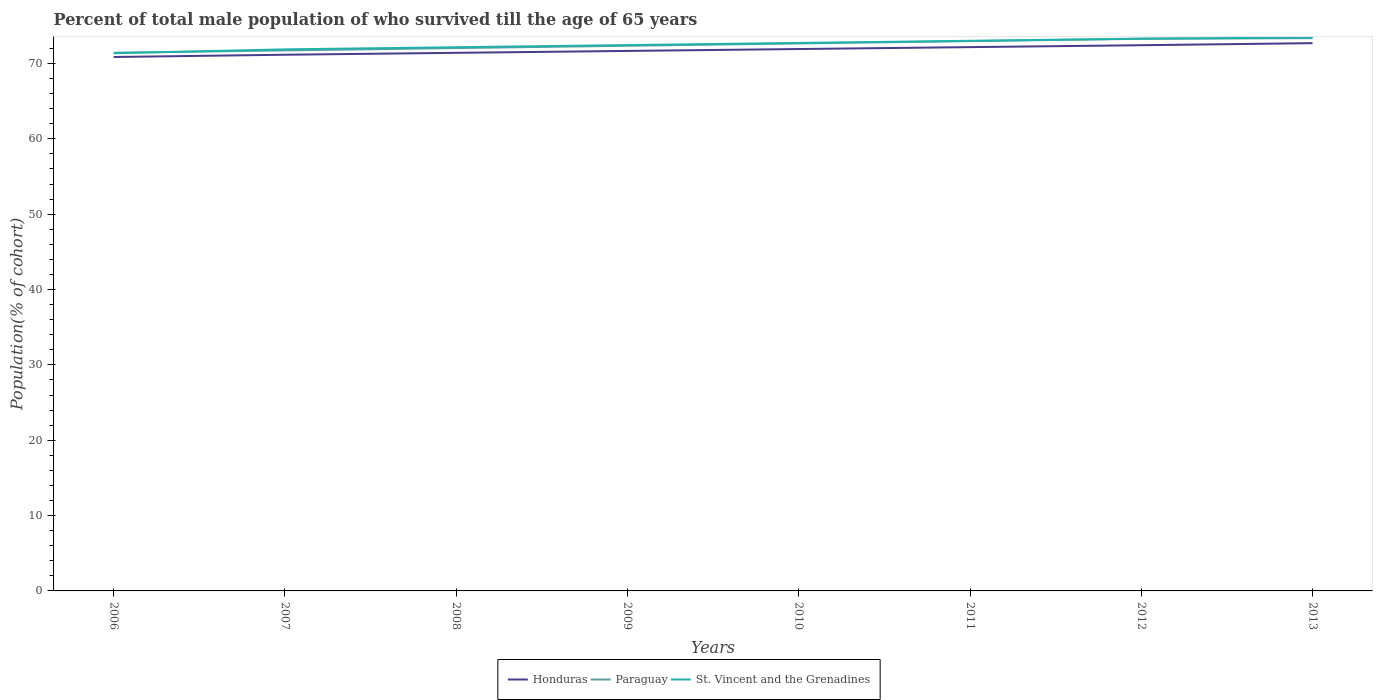Across all years, what is the maximum percentage of total male population who survived till the age of 65 years in Paraguay?
Provide a short and direct response. 71.43. What is the total percentage of total male population who survived till the age of 65 years in Honduras in the graph?
Your response must be concise. -0.5. What is the difference between the highest and the second highest percentage of total male population who survived till the age of 65 years in Honduras?
Keep it short and to the point. 1.84. What is the difference between the highest and the lowest percentage of total male population who survived till the age of 65 years in St. Vincent and the Grenadines?
Give a very brief answer. 4. How many years are there in the graph?
Ensure brevity in your answer.  8. What is the difference between two consecutive major ticks on the Y-axis?
Give a very brief answer. 10. Are the values on the major ticks of Y-axis written in scientific E-notation?
Give a very brief answer. No. Does the graph contain any zero values?
Keep it short and to the point. No. Does the graph contain grids?
Provide a short and direct response. No. What is the title of the graph?
Make the answer very short. Percent of total male population of who survived till the age of 65 years. What is the label or title of the Y-axis?
Your answer should be compact. Population(% of cohort). What is the Population(% of cohort) of Honduras in 2006?
Make the answer very short. 70.86. What is the Population(% of cohort) of Paraguay in 2006?
Your answer should be very brief. 71.43. What is the Population(% of cohort) in St. Vincent and the Grenadines in 2006?
Give a very brief answer. 71.36. What is the Population(% of cohort) of Honduras in 2007?
Offer a very short reply. 71.16. What is the Population(% of cohort) in Paraguay in 2007?
Your response must be concise. 71.74. What is the Population(% of cohort) in St. Vincent and the Grenadines in 2007?
Make the answer very short. 71.87. What is the Population(% of cohort) in Honduras in 2008?
Your answer should be compact. 71.41. What is the Population(% of cohort) of Paraguay in 2008?
Your answer should be very brief. 72.04. What is the Population(% of cohort) of St. Vincent and the Grenadines in 2008?
Provide a short and direct response. 72.16. What is the Population(% of cohort) of Honduras in 2009?
Offer a very short reply. 71.67. What is the Population(% of cohort) in Paraguay in 2009?
Keep it short and to the point. 72.35. What is the Population(% of cohort) in St. Vincent and the Grenadines in 2009?
Provide a succinct answer. 72.44. What is the Population(% of cohort) in Honduras in 2010?
Your response must be concise. 71.92. What is the Population(% of cohort) in Paraguay in 2010?
Give a very brief answer. 72.66. What is the Population(% of cohort) of St. Vincent and the Grenadines in 2010?
Your answer should be compact. 72.73. What is the Population(% of cohort) of Honduras in 2011?
Offer a very short reply. 72.17. What is the Population(% of cohort) of Paraguay in 2011?
Ensure brevity in your answer.  72.97. What is the Population(% of cohort) of St. Vincent and the Grenadines in 2011?
Offer a very short reply. 73.01. What is the Population(% of cohort) in Honduras in 2012?
Make the answer very short. 72.42. What is the Population(% of cohort) in Paraguay in 2012?
Provide a short and direct response. 73.28. What is the Population(% of cohort) of St. Vincent and the Grenadines in 2012?
Offer a very short reply. 73.3. What is the Population(% of cohort) in Honduras in 2013?
Provide a succinct answer. 72.7. What is the Population(% of cohort) of Paraguay in 2013?
Keep it short and to the point. 73.36. What is the Population(% of cohort) in St. Vincent and the Grenadines in 2013?
Your answer should be very brief. 73.44. Across all years, what is the maximum Population(% of cohort) of Honduras?
Your answer should be compact. 72.7. Across all years, what is the maximum Population(% of cohort) of Paraguay?
Provide a succinct answer. 73.36. Across all years, what is the maximum Population(% of cohort) of St. Vincent and the Grenadines?
Offer a terse response. 73.44. Across all years, what is the minimum Population(% of cohort) in Honduras?
Offer a very short reply. 70.86. Across all years, what is the minimum Population(% of cohort) of Paraguay?
Make the answer very short. 71.43. Across all years, what is the minimum Population(% of cohort) in St. Vincent and the Grenadines?
Make the answer very short. 71.36. What is the total Population(% of cohort) of Honduras in the graph?
Make the answer very short. 574.32. What is the total Population(% of cohort) in Paraguay in the graph?
Give a very brief answer. 579.83. What is the total Population(% of cohort) in St. Vincent and the Grenadines in the graph?
Your response must be concise. 580.31. What is the difference between the Population(% of cohort) in Honduras in 2006 and that in 2007?
Give a very brief answer. -0.3. What is the difference between the Population(% of cohort) in Paraguay in 2006 and that in 2007?
Ensure brevity in your answer.  -0.31. What is the difference between the Population(% of cohort) of St. Vincent and the Grenadines in 2006 and that in 2007?
Provide a succinct answer. -0.52. What is the difference between the Population(% of cohort) of Honduras in 2006 and that in 2008?
Provide a succinct answer. -0.55. What is the difference between the Population(% of cohort) of Paraguay in 2006 and that in 2008?
Provide a short and direct response. -0.62. What is the difference between the Population(% of cohort) of St. Vincent and the Grenadines in 2006 and that in 2008?
Your response must be concise. -0.8. What is the difference between the Population(% of cohort) of Honduras in 2006 and that in 2009?
Provide a short and direct response. -0.81. What is the difference between the Population(% of cohort) in Paraguay in 2006 and that in 2009?
Provide a succinct answer. -0.93. What is the difference between the Population(% of cohort) in St. Vincent and the Grenadines in 2006 and that in 2009?
Provide a succinct answer. -1.09. What is the difference between the Population(% of cohort) in Honduras in 2006 and that in 2010?
Offer a terse response. -1.06. What is the difference between the Population(% of cohort) of Paraguay in 2006 and that in 2010?
Give a very brief answer. -1.23. What is the difference between the Population(% of cohort) of St. Vincent and the Grenadines in 2006 and that in 2010?
Keep it short and to the point. -1.37. What is the difference between the Population(% of cohort) of Honduras in 2006 and that in 2011?
Provide a succinct answer. -1.31. What is the difference between the Population(% of cohort) in Paraguay in 2006 and that in 2011?
Ensure brevity in your answer.  -1.54. What is the difference between the Population(% of cohort) in St. Vincent and the Grenadines in 2006 and that in 2011?
Give a very brief answer. -1.65. What is the difference between the Population(% of cohort) in Honduras in 2006 and that in 2012?
Provide a short and direct response. -1.56. What is the difference between the Population(% of cohort) of Paraguay in 2006 and that in 2012?
Provide a short and direct response. -1.85. What is the difference between the Population(% of cohort) of St. Vincent and the Grenadines in 2006 and that in 2012?
Offer a very short reply. -1.94. What is the difference between the Population(% of cohort) in Honduras in 2006 and that in 2013?
Provide a succinct answer. -1.84. What is the difference between the Population(% of cohort) of Paraguay in 2006 and that in 2013?
Make the answer very short. -1.94. What is the difference between the Population(% of cohort) in St. Vincent and the Grenadines in 2006 and that in 2013?
Ensure brevity in your answer.  -2.08. What is the difference between the Population(% of cohort) of Honduras in 2007 and that in 2008?
Your answer should be compact. -0.25. What is the difference between the Population(% of cohort) in Paraguay in 2007 and that in 2008?
Your answer should be compact. -0.31. What is the difference between the Population(% of cohort) in St. Vincent and the Grenadines in 2007 and that in 2008?
Provide a succinct answer. -0.28. What is the difference between the Population(% of cohort) of Honduras in 2007 and that in 2009?
Your answer should be compact. -0.5. What is the difference between the Population(% of cohort) in Paraguay in 2007 and that in 2009?
Offer a very short reply. -0.62. What is the difference between the Population(% of cohort) of St. Vincent and the Grenadines in 2007 and that in 2009?
Provide a short and direct response. -0.57. What is the difference between the Population(% of cohort) of Honduras in 2007 and that in 2010?
Give a very brief answer. -0.76. What is the difference between the Population(% of cohort) of Paraguay in 2007 and that in 2010?
Offer a very short reply. -0.92. What is the difference between the Population(% of cohort) of St. Vincent and the Grenadines in 2007 and that in 2010?
Keep it short and to the point. -0.85. What is the difference between the Population(% of cohort) in Honduras in 2007 and that in 2011?
Provide a short and direct response. -1.01. What is the difference between the Population(% of cohort) of Paraguay in 2007 and that in 2011?
Give a very brief answer. -1.23. What is the difference between the Population(% of cohort) in St. Vincent and the Grenadines in 2007 and that in 2011?
Ensure brevity in your answer.  -1.14. What is the difference between the Population(% of cohort) of Honduras in 2007 and that in 2012?
Provide a succinct answer. -1.26. What is the difference between the Population(% of cohort) in Paraguay in 2007 and that in 2012?
Offer a terse response. -1.54. What is the difference between the Population(% of cohort) in St. Vincent and the Grenadines in 2007 and that in 2012?
Your answer should be compact. -1.42. What is the difference between the Population(% of cohort) of Honduras in 2007 and that in 2013?
Give a very brief answer. -1.54. What is the difference between the Population(% of cohort) of Paraguay in 2007 and that in 2013?
Offer a terse response. -1.63. What is the difference between the Population(% of cohort) of St. Vincent and the Grenadines in 2007 and that in 2013?
Offer a very short reply. -1.57. What is the difference between the Population(% of cohort) in Honduras in 2008 and that in 2009?
Provide a short and direct response. -0.25. What is the difference between the Population(% of cohort) in Paraguay in 2008 and that in 2009?
Provide a short and direct response. -0.31. What is the difference between the Population(% of cohort) of St. Vincent and the Grenadines in 2008 and that in 2009?
Keep it short and to the point. -0.28. What is the difference between the Population(% of cohort) of Honduras in 2008 and that in 2010?
Provide a short and direct response. -0.5. What is the difference between the Population(% of cohort) of Paraguay in 2008 and that in 2010?
Your answer should be very brief. -0.62. What is the difference between the Population(% of cohort) in St. Vincent and the Grenadines in 2008 and that in 2010?
Make the answer very short. -0.57. What is the difference between the Population(% of cohort) of Honduras in 2008 and that in 2011?
Make the answer very short. -0.76. What is the difference between the Population(% of cohort) of Paraguay in 2008 and that in 2011?
Give a very brief answer. -0.92. What is the difference between the Population(% of cohort) of St. Vincent and the Grenadines in 2008 and that in 2011?
Offer a very short reply. -0.85. What is the difference between the Population(% of cohort) of Honduras in 2008 and that in 2012?
Provide a short and direct response. -1.01. What is the difference between the Population(% of cohort) in Paraguay in 2008 and that in 2012?
Offer a terse response. -1.23. What is the difference between the Population(% of cohort) in St. Vincent and the Grenadines in 2008 and that in 2012?
Offer a very short reply. -1.14. What is the difference between the Population(% of cohort) of Honduras in 2008 and that in 2013?
Provide a short and direct response. -1.28. What is the difference between the Population(% of cohort) in Paraguay in 2008 and that in 2013?
Give a very brief answer. -1.32. What is the difference between the Population(% of cohort) in St. Vincent and the Grenadines in 2008 and that in 2013?
Provide a succinct answer. -1.28. What is the difference between the Population(% of cohort) in Honduras in 2009 and that in 2010?
Keep it short and to the point. -0.25. What is the difference between the Population(% of cohort) of Paraguay in 2009 and that in 2010?
Your answer should be very brief. -0.31. What is the difference between the Population(% of cohort) in St. Vincent and the Grenadines in 2009 and that in 2010?
Offer a terse response. -0.28. What is the difference between the Population(% of cohort) of Honduras in 2009 and that in 2011?
Keep it short and to the point. -0.5. What is the difference between the Population(% of cohort) of Paraguay in 2009 and that in 2011?
Your answer should be compact. -0.62. What is the difference between the Population(% of cohort) in St. Vincent and the Grenadines in 2009 and that in 2011?
Ensure brevity in your answer.  -0.57. What is the difference between the Population(% of cohort) of Honduras in 2009 and that in 2012?
Keep it short and to the point. -0.76. What is the difference between the Population(% of cohort) of Paraguay in 2009 and that in 2012?
Your answer should be very brief. -0.92. What is the difference between the Population(% of cohort) of St. Vincent and the Grenadines in 2009 and that in 2012?
Provide a short and direct response. -0.85. What is the difference between the Population(% of cohort) in Honduras in 2009 and that in 2013?
Offer a terse response. -1.03. What is the difference between the Population(% of cohort) of Paraguay in 2009 and that in 2013?
Your answer should be very brief. -1.01. What is the difference between the Population(% of cohort) of St. Vincent and the Grenadines in 2009 and that in 2013?
Ensure brevity in your answer.  -1. What is the difference between the Population(% of cohort) in Honduras in 2010 and that in 2011?
Make the answer very short. -0.25. What is the difference between the Population(% of cohort) in Paraguay in 2010 and that in 2011?
Offer a terse response. -0.31. What is the difference between the Population(% of cohort) of St. Vincent and the Grenadines in 2010 and that in 2011?
Make the answer very short. -0.28. What is the difference between the Population(% of cohort) of Honduras in 2010 and that in 2012?
Offer a very short reply. -0.5. What is the difference between the Population(% of cohort) of Paraguay in 2010 and that in 2012?
Offer a very short reply. -0.62. What is the difference between the Population(% of cohort) of St. Vincent and the Grenadines in 2010 and that in 2012?
Offer a very short reply. -0.57. What is the difference between the Population(% of cohort) of Honduras in 2010 and that in 2013?
Ensure brevity in your answer.  -0.78. What is the difference between the Population(% of cohort) of Paraguay in 2010 and that in 2013?
Offer a terse response. -0.7. What is the difference between the Population(% of cohort) of St. Vincent and the Grenadines in 2010 and that in 2013?
Ensure brevity in your answer.  -0.72. What is the difference between the Population(% of cohort) in Honduras in 2011 and that in 2012?
Provide a succinct answer. -0.25. What is the difference between the Population(% of cohort) in Paraguay in 2011 and that in 2012?
Make the answer very short. -0.31. What is the difference between the Population(% of cohort) in St. Vincent and the Grenadines in 2011 and that in 2012?
Offer a very short reply. -0.28. What is the difference between the Population(% of cohort) of Honduras in 2011 and that in 2013?
Offer a very short reply. -0.53. What is the difference between the Population(% of cohort) in Paraguay in 2011 and that in 2013?
Your response must be concise. -0.4. What is the difference between the Population(% of cohort) in St. Vincent and the Grenadines in 2011 and that in 2013?
Offer a terse response. -0.43. What is the difference between the Population(% of cohort) of Honduras in 2012 and that in 2013?
Offer a very short reply. -0.27. What is the difference between the Population(% of cohort) in Paraguay in 2012 and that in 2013?
Offer a terse response. -0.09. What is the difference between the Population(% of cohort) of St. Vincent and the Grenadines in 2012 and that in 2013?
Your answer should be very brief. -0.15. What is the difference between the Population(% of cohort) of Honduras in 2006 and the Population(% of cohort) of Paraguay in 2007?
Offer a terse response. -0.87. What is the difference between the Population(% of cohort) of Honduras in 2006 and the Population(% of cohort) of St. Vincent and the Grenadines in 2007?
Provide a succinct answer. -1.01. What is the difference between the Population(% of cohort) of Paraguay in 2006 and the Population(% of cohort) of St. Vincent and the Grenadines in 2007?
Provide a short and direct response. -0.45. What is the difference between the Population(% of cohort) of Honduras in 2006 and the Population(% of cohort) of Paraguay in 2008?
Provide a short and direct response. -1.18. What is the difference between the Population(% of cohort) of Honduras in 2006 and the Population(% of cohort) of St. Vincent and the Grenadines in 2008?
Provide a short and direct response. -1.3. What is the difference between the Population(% of cohort) of Paraguay in 2006 and the Population(% of cohort) of St. Vincent and the Grenadines in 2008?
Keep it short and to the point. -0.73. What is the difference between the Population(% of cohort) of Honduras in 2006 and the Population(% of cohort) of Paraguay in 2009?
Offer a terse response. -1.49. What is the difference between the Population(% of cohort) of Honduras in 2006 and the Population(% of cohort) of St. Vincent and the Grenadines in 2009?
Provide a short and direct response. -1.58. What is the difference between the Population(% of cohort) in Paraguay in 2006 and the Population(% of cohort) in St. Vincent and the Grenadines in 2009?
Keep it short and to the point. -1.02. What is the difference between the Population(% of cohort) of Honduras in 2006 and the Population(% of cohort) of Paraguay in 2010?
Your answer should be compact. -1.8. What is the difference between the Population(% of cohort) of Honduras in 2006 and the Population(% of cohort) of St. Vincent and the Grenadines in 2010?
Provide a succinct answer. -1.87. What is the difference between the Population(% of cohort) in Paraguay in 2006 and the Population(% of cohort) in St. Vincent and the Grenadines in 2010?
Your response must be concise. -1.3. What is the difference between the Population(% of cohort) in Honduras in 2006 and the Population(% of cohort) in Paraguay in 2011?
Provide a short and direct response. -2.11. What is the difference between the Population(% of cohort) in Honduras in 2006 and the Population(% of cohort) in St. Vincent and the Grenadines in 2011?
Ensure brevity in your answer.  -2.15. What is the difference between the Population(% of cohort) in Paraguay in 2006 and the Population(% of cohort) in St. Vincent and the Grenadines in 2011?
Give a very brief answer. -1.58. What is the difference between the Population(% of cohort) of Honduras in 2006 and the Population(% of cohort) of Paraguay in 2012?
Offer a terse response. -2.42. What is the difference between the Population(% of cohort) of Honduras in 2006 and the Population(% of cohort) of St. Vincent and the Grenadines in 2012?
Keep it short and to the point. -2.43. What is the difference between the Population(% of cohort) of Paraguay in 2006 and the Population(% of cohort) of St. Vincent and the Grenadines in 2012?
Give a very brief answer. -1.87. What is the difference between the Population(% of cohort) in Honduras in 2006 and the Population(% of cohort) in Paraguay in 2013?
Your answer should be very brief. -2.5. What is the difference between the Population(% of cohort) in Honduras in 2006 and the Population(% of cohort) in St. Vincent and the Grenadines in 2013?
Your answer should be compact. -2.58. What is the difference between the Population(% of cohort) of Paraguay in 2006 and the Population(% of cohort) of St. Vincent and the Grenadines in 2013?
Keep it short and to the point. -2.02. What is the difference between the Population(% of cohort) of Honduras in 2007 and the Population(% of cohort) of Paraguay in 2008?
Your response must be concise. -0.88. What is the difference between the Population(% of cohort) in Honduras in 2007 and the Population(% of cohort) in St. Vincent and the Grenadines in 2008?
Give a very brief answer. -1. What is the difference between the Population(% of cohort) in Paraguay in 2007 and the Population(% of cohort) in St. Vincent and the Grenadines in 2008?
Provide a short and direct response. -0.42. What is the difference between the Population(% of cohort) of Honduras in 2007 and the Population(% of cohort) of Paraguay in 2009?
Make the answer very short. -1.19. What is the difference between the Population(% of cohort) of Honduras in 2007 and the Population(% of cohort) of St. Vincent and the Grenadines in 2009?
Offer a terse response. -1.28. What is the difference between the Population(% of cohort) in Paraguay in 2007 and the Population(% of cohort) in St. Vincent and the Grenadines in 2009?
Provide a short and direct response. -0.71. What is the difference between the Population(% of cohort) in Honduras in 2007 and the Population(% of cohort) in Paraguay in 2010?
Make the answer very short. -1.5. What is the difference between the Population(% of cohort) of Honduras in 2007 and the Population(% of cohort) of St. Vincent and the Grenadines in 2010?
Ensure brevity in your answer.  -1.57. What is the difference between the Population(% of cohort) in Paraguay in 2007 and the Population(% of cohort) in St. Vincent and the Grenadines in 2010?
Offer a terse response. -0.99. What is the difference between the Population(% of cohort) of Honduras in 2007 and the Population(% of cohort) of Paraguay in 2011?
Provide a short and direct response. -1.81. What is the difference between the Population(% of cohort) of Honduras in 2007 and the Population(% of cohort) of St. Vincent and the Grenadines in 2011?
Ensure brevity in your answer.  -1.85. What is the difference between the Population(% of cohort) in Paraguay in 2007 and the Population(% of cohort) in St. Vincent and the Grenadines in 2011?
Offer a terse response. -1.28. What is the difference between the Population(% of cohort) in Honduras in 2007 and the Population(% of cohort) in Paraguay in 2012?
Offer a very short reply. -2.12. What is the difference between the Population(% of cohort) in Honduras in 2007 and the Population(% of cohort) in St. Vincent and the Grenadines in 2012?
Ensure brevity in your answer.  -2.13. What is the difference between the Population(% of cohort) of Paraguay in 2007 and the Population(% of cohort) of St. Vincent and the Grenadines in 2012?
Your answer should be very brief. -1.56. What is the difference between the Population(% of cohort) in Honduras in 2007 and the Population(% of cohort) in Paraguay in 2013?
Offer a very short reply. -2.2. What is the difference between the Population(% of cohort) in Honduras in 2007 and the Population(% of cohort) in St. Vincent and the Grenadines in 2013?
Your answer should be very brief. -2.28. What is the difference between the Population(% of cohort) of Paraguay in 2007 and the Population(% of cohort) of St. Vincent and the Grenadines in 2013?
Offer a very short reply. -1.71. What is the difference between the Population(% of cohort) in Honduras in 2008 and the Population(% of cohort) in Paraguay in 2009?
Make the answer very short. -0.94. What is the difference between the Population(% of cohort) in Honduras in 2008 and the Population(% of cohort) in St. Vincent and the Grenadines in 2009?
Your answer should be very brief. -1.03. What is the difference between the Population(% of cohort) in Paraguay in 2008 and the Population(% of cohort) in St. Vincent and the Grenadines in 2009?
Provide a succinct answer. -0.4. What is the difference between the Population(% of cohort) of Honduras in 2008 and the Population(% of cohort) of Paraguay in 2010?
Keep it short and to the point. -1.25. What is the difference between the Population(% of cohort) in Honduras in 2008 and the Population(% of cohort) in St. Vincent and the Grenadines in 2010?
Your response must be concise. -1.31. What is the difference between the Population(% of cohort) of Paraguay in 2008 and the Population(% of cohort) of St. Vincent and the Grenadines in 2010?
Give a very brief answer. -0.68. What is the difference between the Population(% of cohort) in Honduras in 2008 and the Population(% of cohort) in Paraguay in 2011?
Offer a very short reply. -1.55. What is the difference between the Population(% of cohort) in Honduras in 2008 and the Population(% of cohort) in St. Vincent and the Grenadines in 2011?
Your response must be concise. -1.6. What is the difference between the Population(% of cohort) in Paraguay in 2008 and the Population(% of cohort) in St. Vincent and the Grenadines in 2011?
Provide a succinct answer. -0.97. What is the difference between the Population(% of cohort) of Honduras in 2008 and the Population(% of cohort) of Paraguay in 2012?
Offer a very short reply. -1.86. What is the difference between the Population(% of cohort) in Honduras in 2008 and the Population(% of cohort) in St. Vincent and the Grenadines in 2012?
Make the answer very short. -1.88. What is the difference between the Population(% of cohort) in Paraguay in 2008 and the Population(% of cohort) in St. Vincent and the Grenadines in 2012?
Your response must be concise. -1.25. What is the difference between the Population(% of cohort) of Honduras in 2008 and the Population(% of cohort) of Paraguay in 2013?
Your answer should be very brief. -1.95. What is the difference between the Population(% of cohort) of Honduras in 2008 and the Population(% of cohort) of St. Vincent and the Grenadines in 2013?
Offer a very short reply. -2.03. What is the difference between the Population(% of cohort) in Paraguay in 2008 and the Population(% of cohort) in St. Vincent and the Grenadines in 2013?
Keep it short and to the point. -1.4. What is the difference between the Population(% of cohort) in Honduras in 2009 and the Population(% of cohort) in Paraguay in 2010?
Your answer should be very brief. -0.99. What is the difference between the Population(% of cohort) of Honduras in 2009 and the Population(% of cohort) of St. Vincent and the Grenadines in 2010?
Your answer should be very brief. -1.06. What is the difference between the Population(% of cohort) in Paraguay in 2009 and the Population(% of cohort) in St. Vincent and the Grenadines in 2010?
Your response must be concise. -0.37. What is the difference between the Population(% of cohort) of Honduras in 2009 and the Population(% of cohort) of Paraguay in 2011?
Ensure brevity in your answer.  -1.3. What is the difference between the Population(% of cohort) of Honduras in 2009 and the Population(% of cohort) of St. Vincent and the Grenadines in 2011?
Your response must be concise. -1.34. What is the difference between the Population(% of cohort) in Paraguay in 2009 and the Population(% of cohort) in St. Vincent and the Grenadines in 2011?
Keep it short and to the point. -0.66. What is the difference between the Population(% of cohort) of Honduras in 2009 and the Population(% of cohort) of Paraguay in 2012?
Provide a short and direct response. -1.61. What is the difference between the Population(% of cohort) in Honduras in 2009 and the Population(% of cohort) in St. Vincent and the Grenadines in 2012?
Give a very brief answer. -1.63. What is the difference between the Population(% of cohort) in Paraguay in 2009 and the Population(% of cohort) in St. Vincent and the Grenadines in 2012?
Keep it short and to the point. -0.94. What is the difference between the Population(% of cohort) of Honduras in 2009 and the Population(% of cohort) of Paraguay in 2013?
Provide a succinct answer. -1.7. What is the difference between the Population(% of cohort) of Honduras in 2009 and the Population(% of cohort) of St. Vincent and the Grenadines in 2013?
Offer a very short reply. -1.78. What is the difference between the Population(% of cohort) in Paraguay in 2009 and the Population(% of cohort) in St. Vincent and the Grenadines in 2013?
Offer a terse response. -1.09. What is the difference between the Population(% of cohort) in Honduras in 2010 and the Population(% of cohort) in Paraguay in 2011?
Give a very brief answer. -1.05. What is the difference between the Population(% of cohort) in Honduras in 2010 and the Population(% of cohort) in St. Vincent and the Grenadines in 2011?
Provide a succinct answer. -1.09. What is the difference between the Population(% of cohort) in Paraguay in 2010 and the Population(% of cohort) in St. Vincent and the Grenadines in 2011?
Provide a short and direct response. -0.35. What is the difference between the Population(% of cohort) in Honduras in 2010 and the Population(% of cohort) in Paraguay in 2012?
Offer a terse response. -1.36. What is the difference between the Population(% of cohort) in Honduras in 2010 and the Population(% of cohort) in St. Vincent and the Grenadines in 2012?
Offer a terse response. -1.38. What is the difference between the Population(% of cohort) in Paraguay in 2010 and the Population(% of cohort) in St. Vincent and the Grenadines in 2012?
Your response must be concise. -0.64. What is the difference between the Population(% of cohort) of Honduras in 2010 and the Population(% of cohort) of Paraguay in 2013?
Your answer should be very brief. -1.45. What is the difference between the Population(% of cohort) of Honduras in 2010 and the Population(% of cohort) of St. Vincent and the Grenadines in 2013?
Keep it short and to the point. -1.52. What is the difference between the Population(% of cohort) in Paraguay in 2010 and the Population(% of cohort) in St. Vincent and the Grenadines in 2013?
Ensure brevity in your answer.  -0.78. What is the difference between the Population(% of cohort) of Honduras in 2011 and the Population(% of cohort) of Paraguay in 2012?
Keep it short and to the point. -1.11. What is the difference between the Population(% of cohort) of Honduras in 2011 and the Population(% of cohort) of St. Vincent and the Grenadines in 2012?
Your response must be concise. -1.12. What is the difference between the Population(% of cohort) in Paraguay in 2011 and the Population(% of cohort) in St. Vincent and the Grenadines in 2012?
Make the answer very short. -0.33. What is the difference between the Population(% of cohort) of Honduras in 2011 and the Population(% of cohort) of Paraguay in 2013?
Make the answer very short. -1.19. What is the difference between the Population(% of cohort) of Honduras in 2011 and the Population(% of cohort) of St. Vincent and the Grenadines in 2013?
Ensure brevity in your answer.  -1.27. What is the difference between the Population(% of cohort) of Paraguay in 2011 and the Population(% of cohort) of St. Vincent and the Grenadines in 2013?
Your answer should be compact. -0.47. What is the difference between the Population(% of cohort) of Honduras in 2012 and the Population(% of cohort) of Paraguay in 2013?
Keep it short and to the point. -0.94. What is the difference between the Population(% of cohort) of Honduras in 2012 and the Population(% of cohort) of St. Vincent and the Grenadines in 2013?
Your answer should be very brief. -1.02. What is the difference between the Population(% of cohort) in Paraguay in 2012 and the Population(% of cohort) in St. Vincent and the Grenadines in 2013?
Your answer should be compact. -0.17. What is the average Population(% of cohort) in Honduras per year?
Make the answer very short. 71.79. What is the average Population(% of cohort) of Paraguay per year?
Keep it short and to the point. 72.48. What is the average Population(% of cohort) in St. Vincent and the Grenadines per year?
Provide a succinct answer. 72.54. In the year 2006, what is the difference between the Population(% of cohort) in Honduras and Population(% of cohort) in Paraguay?
Keep it short and to the point. -0.57. In the year 2006, what is the difference between the Population(% of cohort) of Honduras and Population(% of cohort) of St. Vincent and the Grenadines?
Give a very brief answer. -0.5. In the year 2006, what is the difference between the Population(% of cohort) in Paraguay and Population(% of cohort) in St. Vincent and the Grenadines?
Ensure brevity in your answer.  0.07. In the year 2007, what is the difference between the Population(% of cohort) of Honduras and Population(% of cohort) of Paraguay?
Make the answer very short. -0.57. In the year 2007, what is the difference between the Population(% of cohort) in Honduras and Population(% of cohort) in St. Vincent and the Grenadines?
Offer a very short reply. -0.71. In the year 2007, what is the difference between the Population(% of cohort) of Paraguay and Population(% of cohort) of St. Vincent and the Grenadines?
Provide a succinct answer. -0.14. In the year 2008, what is the difference between the Population(% of cohort) of Honduras and Population(% of cohort) of Paraguay?
Make the answer very short. -0.63. In the year 2008, what is the difference between the Population(% of cohort) in Honduras and Population(% of cohort) in St. Vincent and the Grenadines?
Provide a succinct answer. -0.74. In the year 2008, what is the difference between the Population(% of cohort) in Paraguay and Population(% of cohort) in St. Vincent and the Grenadines?
Offer a very short reply. -0.11. In the year 2009, what is the difference between the Population(% of cohort) in Honduras and Population(% of cohort) in Paraguay?
Give a very brief answer. -0.69. In the year 2009, what is the difference between the Population(% of cohort) of Honduras and Population(% of cohort) of St. Vincent and the Grenadines?
Give a very brief answer. -0.78. In the year 2009, what is the difference between the Population(% of cohort) in Paraguay and Population(% of cohort) in St. Vincent and the Grenadines?
Make the answer very short. -0.09. In the year 2010, what is the difference between the Population(% of cohort) in Honduras and Population(% of cohort) in Paraguay?
Ensure brevity in your answer.  -0.74. In the year 2010, what is the difference between the Population(% of cohort) in Honduras and Population(% of cohort) in St. Vincent and the Grenadines?
Keep it short and to the point. -0.81. In the year 2010, what is the difference between the Population(% of cohort) of Paraguay and Population(% of cohort) of St. Vincent and the Grenadines?
Provide a succinct answer. -0.07. In the year 2011, what is the difference between the Population(% of cohort) of Honduras and Population(% of cohort) of Paraguay?
Your answer should be compact. -0.8. In the year 2011, what is the difference between the Population(% of cohort) in Honduras and Population(% of cohort) in St. Vincent and the Grenadines?
Your answer should be compact. -0.84. In the year 2011, what is the difference between the Population(% of cohort) of Paraguay and Population(% of cohort) of St. Vincent and the Grenadines?
Give a very brief answer. -0.04. In the year 2012, what is the difference between the Population(% of cohort) of Honduras and Population(% of cohort) of Paraguay?
Ensure brevity in your answer.  -0.85. In the year 2012, what is the difference between the Population(% of cohort) in Honduras and Population(% of cohort) in St. Vincent and the Grenadines?
Ensure brevity in your answer.  -0.87. In the year 2012, what is the difference between the Population(% of cohort) in Paraguay and Population(% of cohort) in St. Vincent and the Grenadines?
Offer a terse response. -0.02. In the year 2013, what is the difference between the Population(% of cohort) in Honduras and Population(% of cohort) in Paraguay?
Offer a terse response. -0.67. In the year 2013, what is the difference between the Population(% of cohort) in Honduras and Population(% of cohort) in St. Vincent and the Grenadines?
Your answer should be compact. -0.75. In the year 2013, what is the difference between the Population(% of cohort) of Paraguay and Population(% of cohort) of St. Vincent and the Grenadines?
Offer a terse response. -0.08. What is the ratio of the Population(% of cohort) in Paraguay in 2006 to that in 2007?
Keep it short and to the point. 1. What is the ratio of the Population(% of cohort) in Honduras in 2006 to that in 2008?
Your response must be concise. 0.99. What is the ratio of the Population(% of cohort) in St. Vincent and the Grenadines in 2006 to that in 2008?
Offer a very short reply. 0.99. What is the ratio of the Population(% of cohort) of Honduras in 2006 to that in 2009?
Keep it short and to the point. 0.99. What is the ratio of the Population(% of cohort) in Paraguay in 2006 to that in 2009?
Keep it short and to the point. 0.99. What is the ratio of the Population(% of cohort) of St. Vincent and the Grenadines in 2006 to that in 2010?
Your response must be concise. 0.98. What is the ratio of the Population(% of cohort) in Honduras in 2006 to that in 2011?
Provide a succinct answer. 0.98. What is the ratio of the Population(% of cohort) of Paraguay in 2006 to that in 2011?
Provide a succinct answer. 0.98. What is the ratio of the Population(% of cohort) of St. Vincent and the Grenadines in 2006 to that in 2011?
Your answer should be very brief. 0.98. What is the ratio of the Population(% of cohort) of Honduras in 2006 to that in 2012?
Give a very brief answer. 0.98. What is the ratio of the Population(% of cohort) in Paraguay in 2006 to that in 2012?
Your answer should be compact. 0.97. What is the ratio of the Population(% of cohort) of St. Vincent and the Grenadines in 2006 to that in 2012?
Make the answer very short. 0.97. What is the ratio of the Population(% of cohort) of Honduras in 2006 to that in 2013?
Ensure brevity in your answer.  0.97. What is the ratio of the Population(% of cohort) in Paraguay in 2006 to that in 2013?
Offer a terse response. 0.97. What is the ratio of the Population(% of cohort) in St. Vincent and the Grenadines in 2006 to that in 2013?
Provide a succinct answer. 0.97. What is the ratio of the Population(% of cohort) of Paraguay in 2007 to that in 2008?
Your answer should be compact. 1. What is the ratio of the Population(% of cohort) in St. Vincent and the Grenadines in 2007 to that in 2008?
Provide a short and direct response. 1. What is the ratio of the Population(% of cohort) in Honduras in 2007 to that in 2010?
Your answer should be compact. 0.99. What is the ratio of the Population(% of cohort) in Paraguay in 2007 to that in 2010?
Offer a very short reply. 0.99. What is the ratio of the Population(% of cohort) in St. Vincent and the Grenadines in 2007 to that in 2010?
Offer a very short reply. 0.99. What is the ratio of the Population(% of cohort) in Paraguay in 2007 to that in 2011?
Offer a terse response. 0.98. What is the ratio of the Population(% of cohort) of St. Vincent and the Grenadines in 2007 to that in 2011?
Your answer should be compact. 0.98. What is the ratio of the Population(% of cohort) in Honduras in 2007 to that in 2012?
Your answer should be very brief. 0.98. What is the ratio of the Population(% of cohort) of Paraguay in 2007 to that in 2012?
Keep it short and to the point. 0.98. What is the ratio of the Population(% of cohort) in St. Vincent and the Grenadines in 2007 to that in 2012?
Give a very brief answer. 0.98. What is the ratio of the Population(% of cohort) in Honduras in 2007 to that in 2013?
Ensure brevity in your answer.  0.98. What is the ratio of the Population(% of cohort) of Paraguay in 2007 to that in 2013?
Provide a short and direct response. 0.98. What is the ratio of the Population(% of cohort) of St. Vincent and the Grenadines in 2007 to that in 2013?
Provide a short and direct response. 0.98. What is the ratio of the Population(% of cohort) of Honduras in 2008 to that in 2009?
Ensure brevity in your answer.  1. What is the ratio of the Population(% of cohort) of Paraguay in 2008 to that in 2009?
Provide a succinct answer. 1. What is the ratio of the Population(% of cohort) of Paraguay in 2008 to that in 2010?
Offer a very short reply. 0.99. What is the ratio of the Population(% of cohort) of St. Vincent and the Grenadines in 2008 to that in 2010?
Provide a succinct answer. 0.99. What is the ratio of the Population(% of cohort) in Paraguay in 2008 to that in 2011?
Provide a succinct answer. 0.99. What is the ratio of the Population(% of cohort) of St. Vincent and the Grenadines in 2008 to that in 2011?
Your answer should be very brief. 0.99. What is the ratio of the Population(% of cohort) of Honduras in 2008 to that in 2012?
Keep it short and to the point. 0.99. What is the ratio of the Population(% of cohort) of Paraguay in 2008 to that in 2012?
Provide a succinct answer. 0.98. What is the ratio of the Population(% of cohort) of St. Vincent and the Grenadines in 2008 to that in 2012?
Your answer should be compact. 0.98. What is the ratio of the Population(% of cohort) of Honduras in 2008 to that in 2013?
Ensure brevity in your answer.  0.98. What is the ratio of the Population(% of cohort) of Paraguay in 2008 to that in 2013?
Provide a short and direct response. 0.98. What is the ratio of the Population(% of cohort) in St. Vincent and the Grenadines in 2008 to that in 2013?
Make the answer very short. 0.98. What is the ratio of the Population(% of cohort) in Honduras in 2009 to that in 2010?
Make the answer very short. 1. What is the ratio of the Population(% of cohort) of St. Vincent and the Grenadines in 2009 to that in 2010?
Offer a very short reply. 1. What is the ratio of the Population(% of cohort) in Honduras in 2009 to that in 2011?
Offer a terse response. 0.99. What is the ratio of the Population(% of cohort) of Paraguay in 2009 to that in 2011?
Offer a terse response. 0.99. What is the ratio of the Population(% of cohort) of St. Vincent and the Grenadines in 2009 to that in 2011?
Offer a terse response. 0.99. What is the ratio of the Population(% of cohort) in Honduras in 2009 to that in 2012?
Provide a short and direct response. 0.99. What is the ratio of the Population(% of cohort) of Paraguay in 2009 to that in 2012?
Offer a terse response. 0.99. What is the ratio of the Population(% of cohort) of St. Vincent and the Grenadines in 2009 to that in 2012?
Your answer should be compact. 0.99. What is the ratio of the Population(% of cohort) of Honduras in 2009 to that in 2013?
Keep it short and to the point. 0.99. What is the ratio of the Population(% of cohort) in Paraguay in 2009 to that in 2013?
Give a very brief answer. 0.99. What is the ratio of the Population(% of cohort) in St. Vincent and the Grenadines in 2009 to that in 2013?
Make the answer very short. 0.99. What is the ratio of the Population(% of cohort) in Paraguay in 2010 to that in 2011?
Provide a succinct answer. 1. What is the ratio of the Population(% of cohort) in Honduras in 2010 to that in 2012?
Your response must be concise. 0.99. What is the ratio of the Population(% of cohort) of Honduras in 2010 to that in 2013?
Your response must be concise. 0.99. What is the ratio of the Population(% of cohort) of Paraguay in 2010 to that in 2013?
Give a very brief answer. 0.99. What is the ratio of the Population(% of cohort) in St. Vincent and the Grenadines in 2010 to that in 2013?
Ensure brevity in your answer.  0.99. What is the ratio of the Population(% of cohort) of Honduras in 2011 to that in 2012?
Ensure brevity in your answer.  1. What is the ratio of the Population(% of cohort) in Paraguay in 2011 to that in 2013?
Make the answer very short. 0.99. What is the ratio of the Population(% of cohort) in Honduras in 2012 to that in 2013?
Your response must be concise. 1. What is the ratio of the Population(% of cohort) of Paraguay in 2012 to that in 2013?
Give a very brief answer. 1. What is the ratio of the Population(% of cohort) in St. Vincent and the Grenadines in 2012 to that in 2013?
Make the answer very short. 1. What is the difference between the highest and the second highest Population(% of cohort) of Honduras?
Provide a short and direct response. 0.27. What is the difference between the highest and the second highest Population(% of cohort) in Paraguay?
Provide a succinct answer. 0.09. What is the difference between the highest and the second highest Population(% of cohort) in St. Vincent and the Grenadines?
Ensure brevity in your answer.  0.15. What is the difference between the highest and the lowest Population(% of cohort) in Honduras?
Offer a very short reply. 1.84. What is the difference between the highest and the lowest Population(% of cohort) of Paraguay?
Make the answer very short. 1.94. What is the difference between the highest and the lowest Population(% of cohort) of St. Vincent and the Grenadines?
Your answer should be very brief. 2.08. 